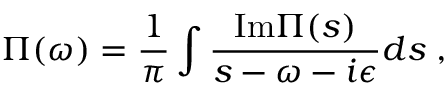<formula> <loc_0><loc_0><loc_500><loc_500>\Pi ( \omega ) = { \frac { 1 } { \pi } } \int { \frac { I m \Pi ( s ) } { s - \omega - i \epsilon } } d s \, ,</formula> 